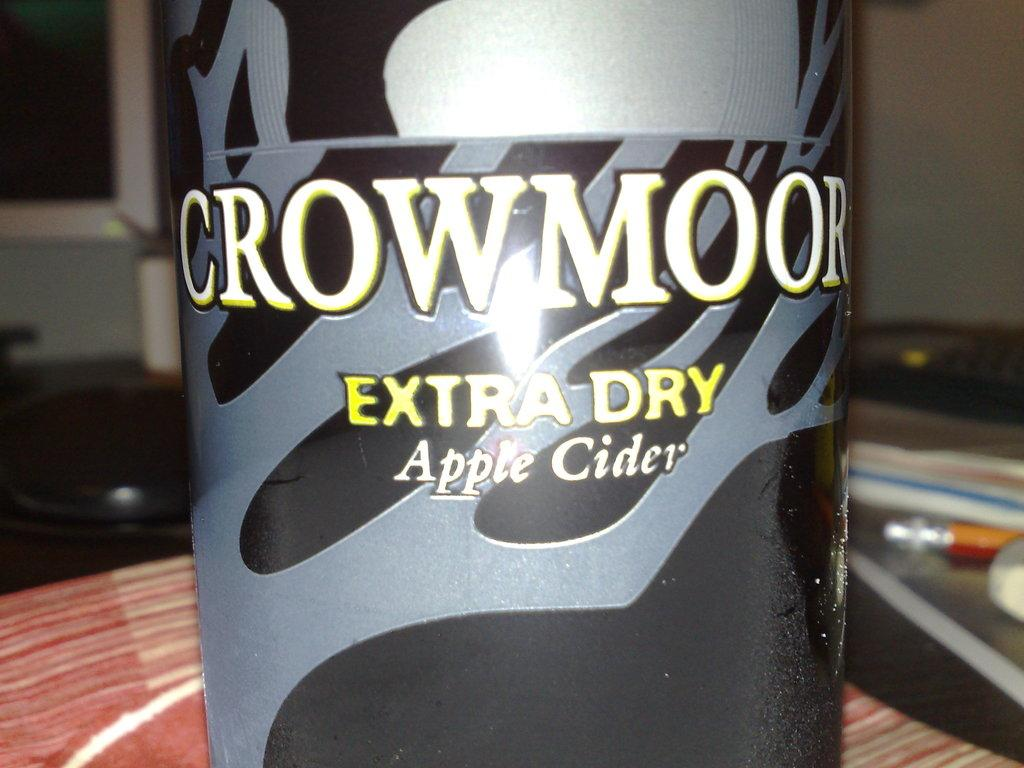Provide a one-sentence caption for the provided image. CrowMoor extra dry apple cider in a bottle. 